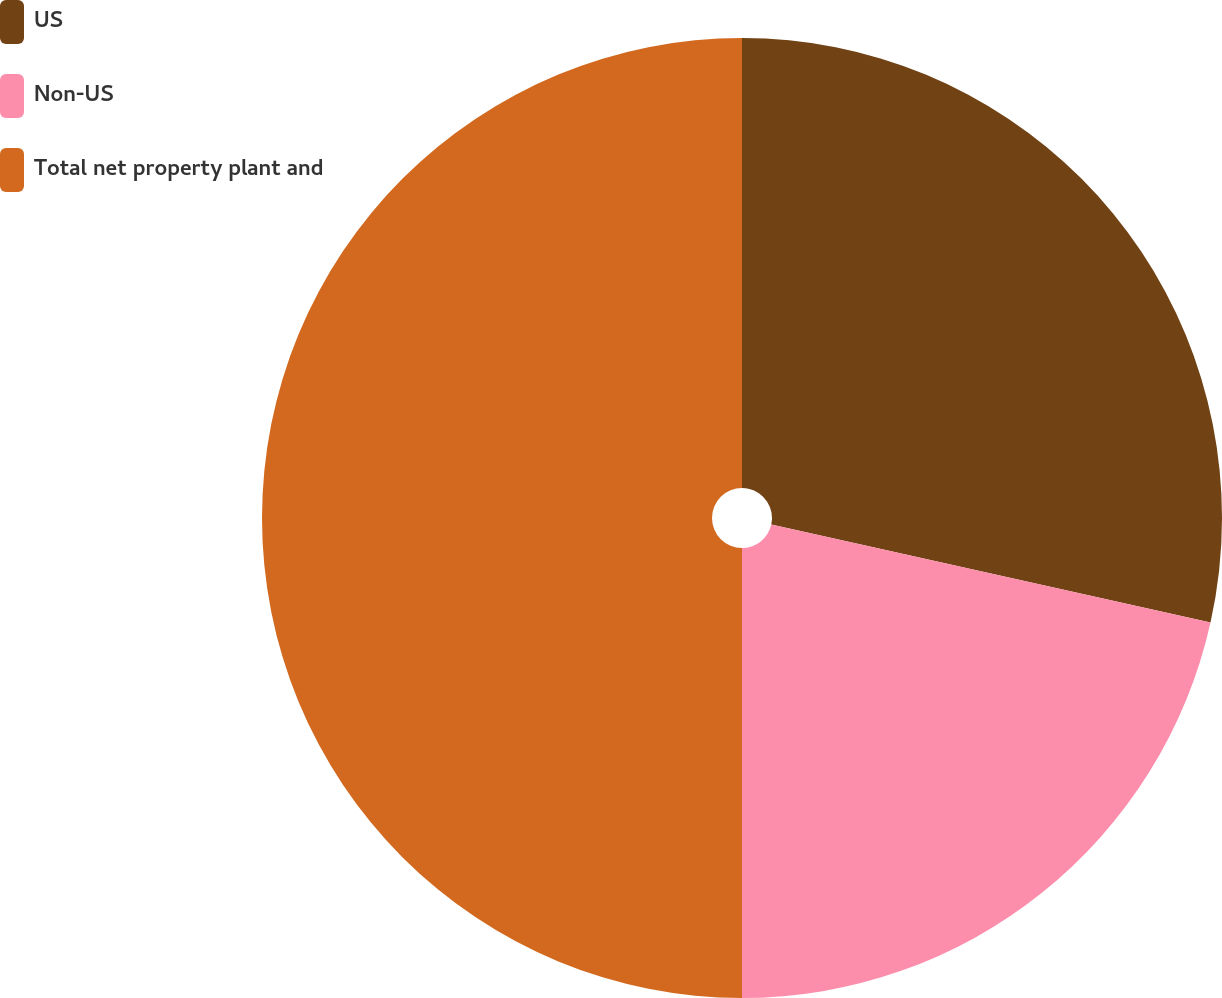Convert chart to OTSL. <chart><loc_0><loc_0><loc_500><loc_500><pie_chart><fcel>US<fcel>Non-US<fcel>Total net property plant and<nl><fcel>28.49%<fcel>21.51%<fcel>50.0%<nl></chart> 